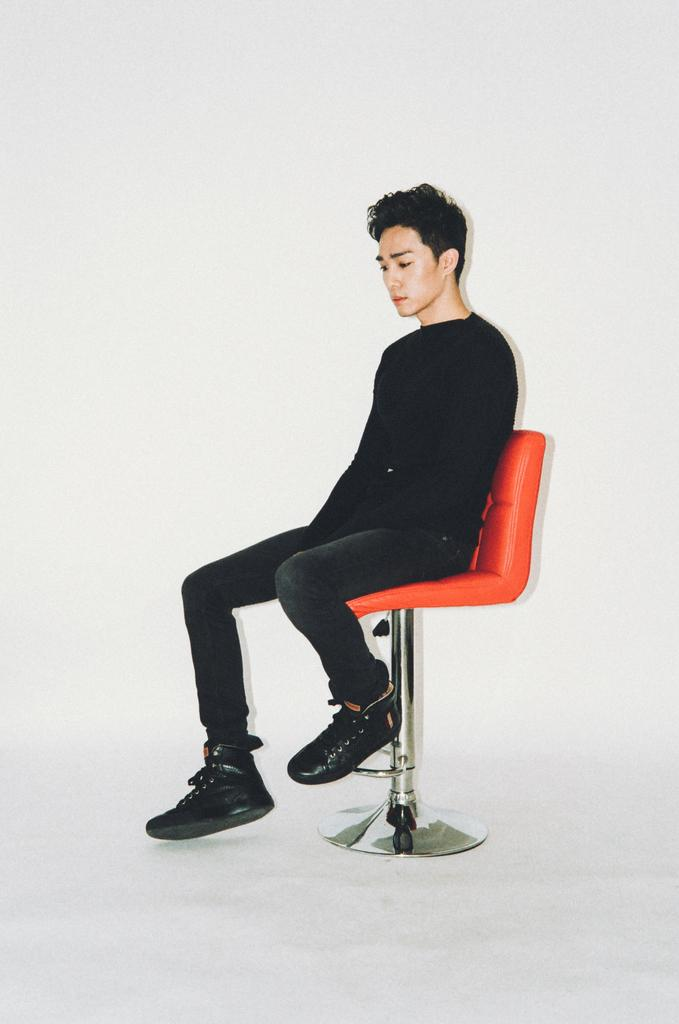What is the main subject of the image? There is a person sitting on a chair in the image. What can be seen in the background of the image? The background of the image is white. What type of apparel is the person wearing on their voyage in the image? There is no indication of a voyage or any specific apparel in the image. 